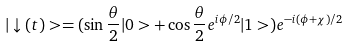Convert formula to latex. <formula><loc_0><loc_0><loc_500><loc_500>| \downarrow ( t ) > = ( \sin \frac { \theta } { 2 } | 0 > + \cos \frac { \theta } { 2 } e ^ { i \phi / 2 } | 1 > ) e ^ { - i ( \phi + \chi ) / 2 }</formula> 